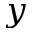Convert formula to latex. <formula><loc_0><loc_0><loc_500><loc_500>y</formula> 